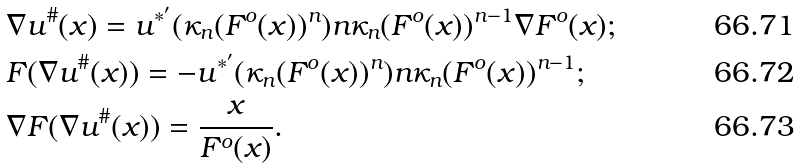Convert formula to latex. <formula><loc_0><loc_0><loc_500><loc_500>& \nabla u ^ { \# } ( x ) = u ^ { * ^ { \prime } } ( \kappa _ { n } ( F ^ { o } ( x ) ) ^ { n } ) n \kappa _ { n } ( F ^ { o } ( x ) ) ^ { n - 1 } \nabla F ^ { o } ( x ) ; \\ & F ( \nabla u ^ { \# } ( x ) ) = - u ^ { * ^ { \prime } } ( \kappa _ { n } ( F ^ { o } ( x ) ) ^ { n } ) n \kappa _ { n } ( F ^ { o } ( x ) ) ^ { n - 1 } ; \\ & \nabla F ( \nabla u ^ { \# } ( x ) ) = \frac { x } { F ^ { o } ( x ) } .</formula> 